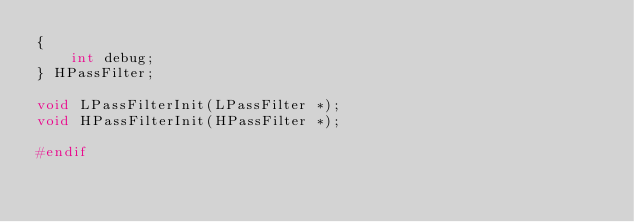Convert code to text. <code><loc_0><loc_0><loc_500><loc_500><_C_>{
    int debug;
} HPassFilter;

void LPassFilterInit(LPassFilter *);
void HPassFilterInit(HPassFilter *);

#endif
</code> 